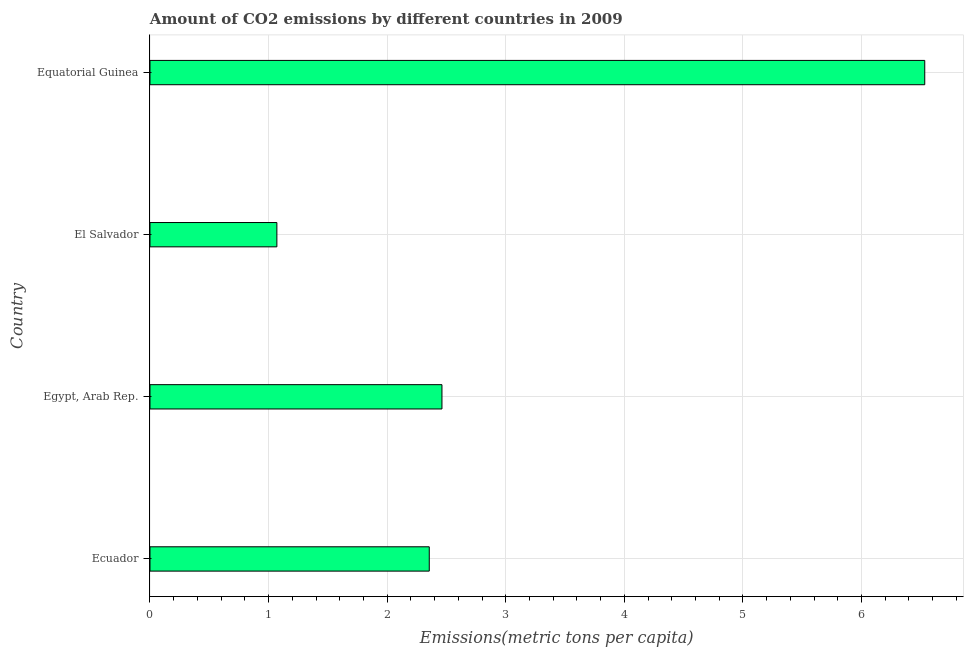Does the graph contain any zero values?
Provide a short and direct response. No. What is the title of the graph?
Provide a succinct answer. Amount of CO2 emissions by different countries in 2009. What is the label or title of the X-axis?
Make the answer very short. Emissions(metric tons per capita). What is the label or title of the Y-axis?
Ensure brevity in your answer.  Country. What is the amount of co2 emissions in Ecuador?
Keep it short and to the point. 2.36. Across all countries, what is the maximum amount of co2 emissions?
Your answer should be compact. 6.53. Across all countries, what is the minimum amount of co2 emissions?
Provide a short and direct response. 1.07. In which country was the amount of co2 emissions maximum?
Give a very brief answer. Equatorial Guinea. In which country was the amount of co2 emissions minimum?
Make the answer very short. El Salvador. What is the sum of the amount of co2 emissions?
Provide a succinct answer. 12.42. What is the difference between the amount of co2 emissions in Egypt, Arab Rep. and El Salvador?
Your answer should be very brief. 1.39. What is the average amount of co2 emissions per country?
Keep it short and to the point. 3.1. What is the median amount of co2 emissions?
Provide a succinct answer. 2.41. In how many countries, is the amount of co2 emissions greater than 6.2 metric tons per capita?
Keep it short and to the point. 1. What is the ratio of the amount of co2 emissions in Ecuador to that in Egypt, Arab Rep.?
Ensure brevity in your answer.  0.96. Is the difference between the amount of co2 emissions in Ecuador and Equatorial Guinea greater than the difference between any two countries?
Your answer should be very brief. No. What is the difference between the highest and the second highest amount of co2 emissions?
Offer a very short reply. 4.07. Is the sum of the amount of co2 emissions in Ecuador and Equatorial Guinea greater than the maximum amount of co2 emissions across all countries?
Ensure brevity in your answer.  Yes. What is the difference between the highest and the lowest amount of co2 emissions?
Your answer should be compact. 5.46. How many bars are there?
Offer a terse response. 4. Are all the bars in the graph horizontal?
Offer a very short reply. Yes. What is the difference between two consecutive major ticks on the X-axis?
Your answer should be compact. 1. Are the values on the major ticks of X-axis written in scientific E-notation?
Offer a very short reply. No. What is the Emissions(metric tons per capita) of Ecuador?
Offer a terse response. 2.36. What is the Emissions(metric tons per capita) of Egypt, Arab Rep.?
Provide a succinct answer. 2.46. What is the Emissions(metric tons per capita) of El Salvador?
Make the answer very short. 1.07. What is the Emissions(metric tons per capita) in Equatorial Guinea?
Keep it short and to the point. 6.53. What is the difference between the Emissions(metric tons per capita) in Ecuador and Egypt, Arab Rep.?
Provide a succinct answer. -0.11. What is the difference between the Emissions(metric tons per capita) in Ecuador and El Salvador?
Provide a short and direct response. 1.29. What is the difference between the Emissions(metric tons per capita) in Ecuador and Equatorial Guinea?
Keep it short and to the point. -4.18. What is the difference between the Emissions(metric tons per capita) in Egypt, Arab Rep. and El Salvador?
Keep it short and to the point. 1.39. What is the difference between the Emissions(metric tons per capita) in Egypt, Arab Rep. and Equatorial Guinea?
Make the answer very short. -4.07. What is the difference between the Emissions(metric tons per capita) in El Salvador and Equatorial Guinea?
Keep it short and to the point. -5.46. What is the ratio of the Emissions(metric tons per capita) in Ecuador to that in Egypt, Arab Rep.?
Offer a terse response. 0.96. What is the ratio of the Emissions(metric tons per capita) in Ecuador to that in El Salvador?
Make the answer very short. 2.2. What is the ratio of the Emissions(metric tons per capita) in Ecuador to that in Equatorial Guinea?
Your response must be concise. 0.36. What is the ratio of the Emissions(metric tons per capita) in Egypt, Arab Rep. to that in El Salvador?
Provide a short and direct response. 2.3. What is the ratio of the Emissions(metric tons per capita) in Egypt, Arab Rep. to that in Equatorial Guinea?
Offer a very short reply. 0.38. What is the ratio of the Emissions(metric tons per capita) in El Salvador to that in Equatorial Guinea?
Offer a terse response. 0.16. 